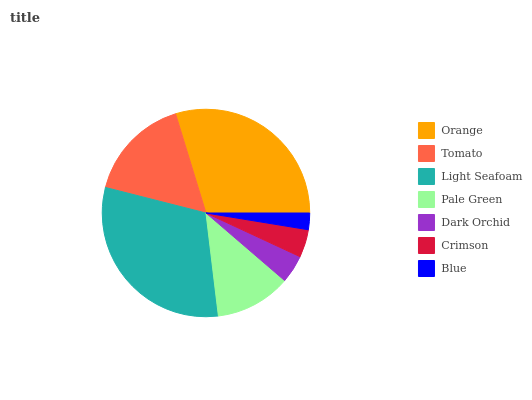Is Blue the minimum?
Answer yes or no. Yes. Is Light Seafoam the maximum?
Answer yes or no. Yes. Is Tomato the minimum?
Answer yes or no. No. Is Tomato the maximum?
Answer yes or no. No. Is Orange greater than Tomato?
Answer yes or no. Yes. Is Tomato less than Orange?
Answer yes or no. Yes. Is Tomato greater than Orange?
Answer yes or no. No. Is Orange less than Tomato?
Answer yes or no. No. Is Pale Green the high median?
Answer yes or no. Yes. Is Pale Green the low median?
Answer yes or no. Yes. Is Tomato the high median?
Answer yes or no. No. Is Blue the low median?
Answer yes or no. No. 